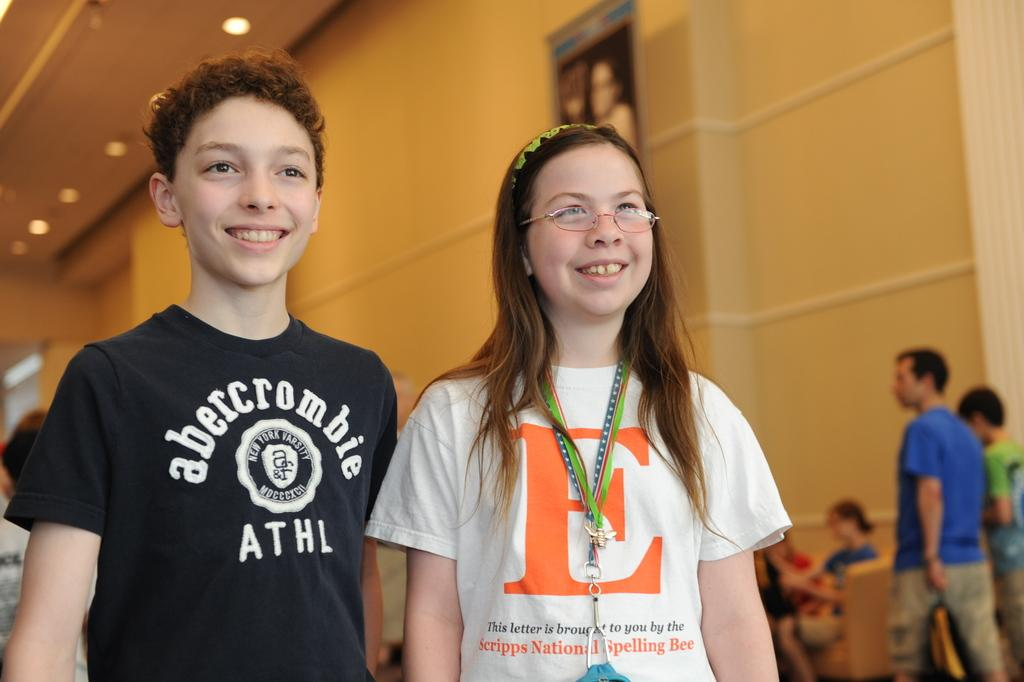How many children are in the image? There are two children in the image. What expression do the children have? The children are smiling. Can you describe the people in the image? There are people in the image, but their specific details are not mentioned in the facts. What can be seen in the background of the image? There is a wall, a ceiling, lights, and a frame in the background of the image. What type of punishment is being administered to the children in the image? There is no indication of punishment in the image; the children are smiling. What event is taking place on the stage in the image? There is no stage present in the image. 